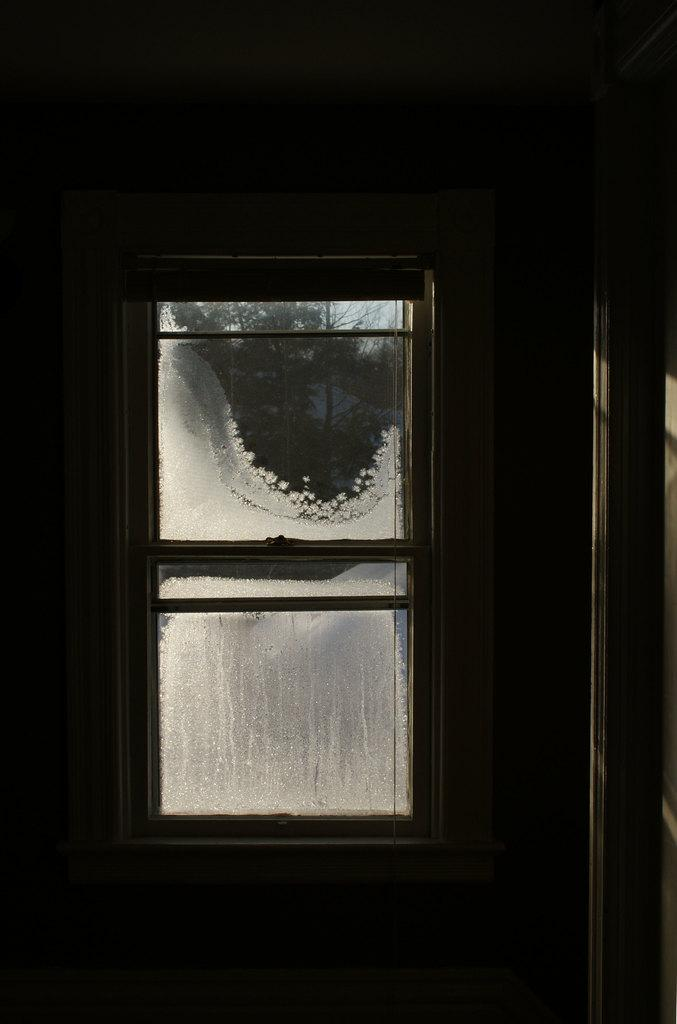What is located in the middle of the image? There is a glass window in the middle of the image. What can be seen through the glass window? Trees are visible outside the glass window. What is the color of the background in the image? The background of the image appears to be black. What type of garden can be seen through the glass window? There is no garden visible through the glass window; only trees are present. How does the ice interact with the glass window in the image? There is no ice present in the image, so it cannot interact with the glass window. 